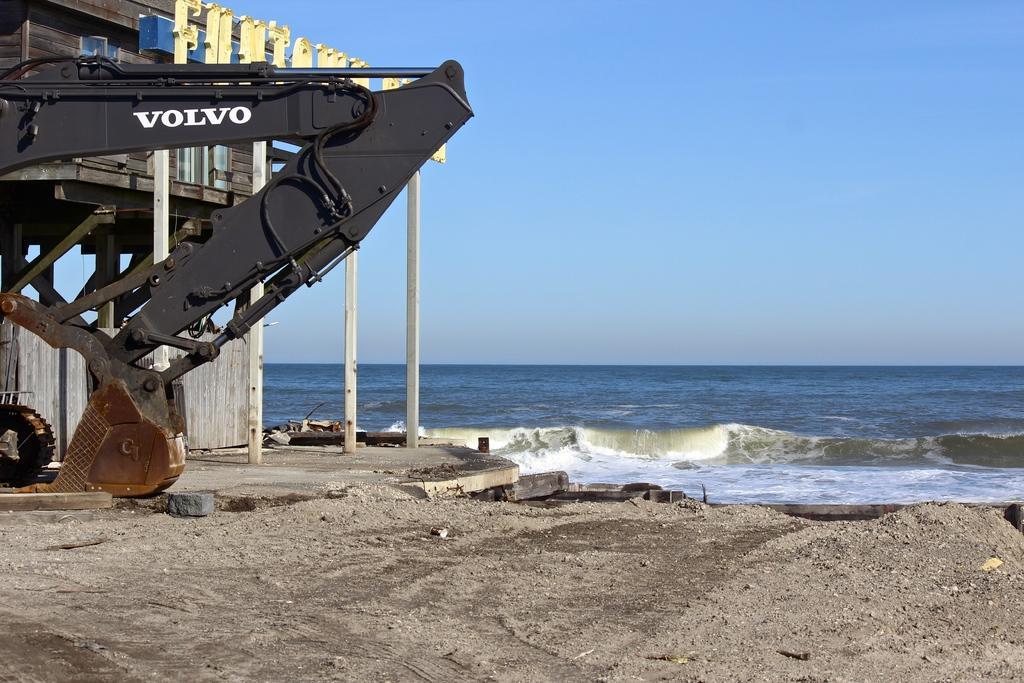How would you summarize this image in a sentence or two? In the picture there is a sea and in front of the sea there is a wooden building and beside the building there is a crane, on the right side there is a land covered with sand. 